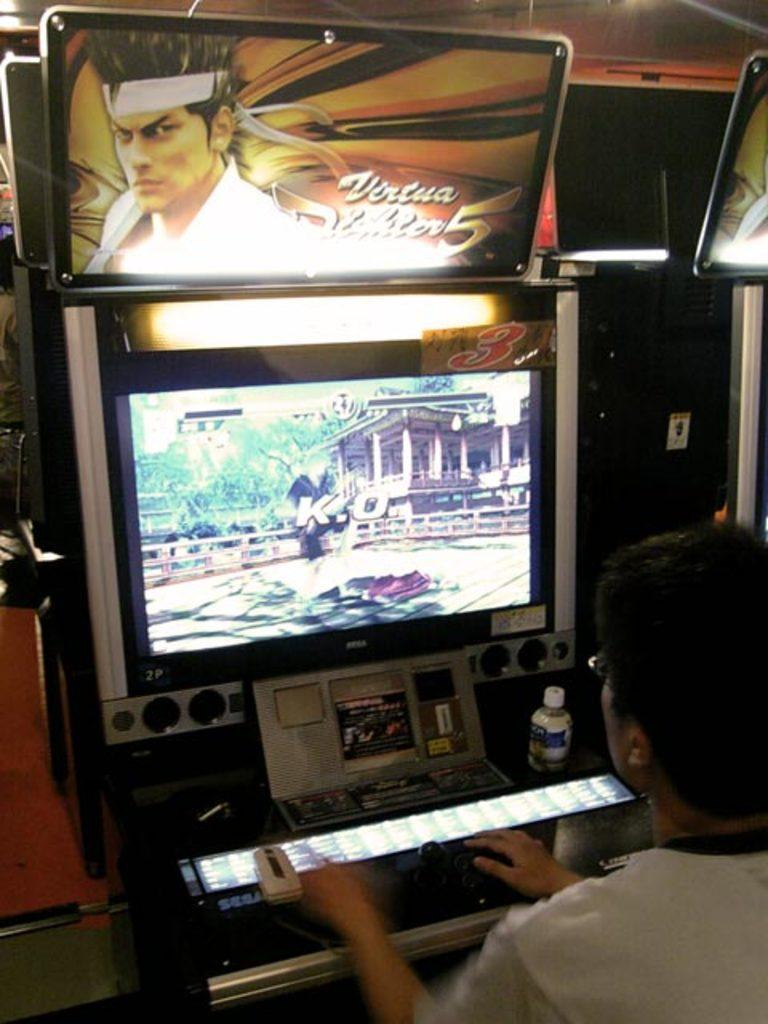<image>
Create a compact narrative representing the image presented. a man sitting at a game playing virtua fighter 5 